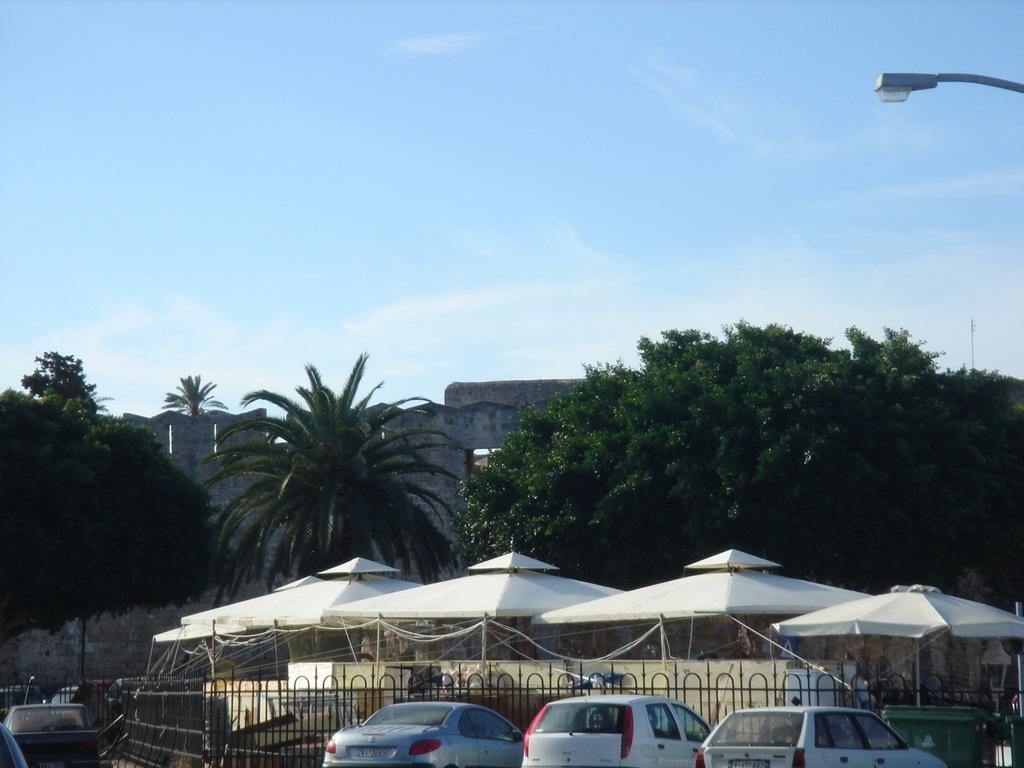In one or two sentences, can you explain what this image depicts? At the bottom of the image there are few vehicles parked on the road, in front of them there is a shed and fencing with metal. In the middle of the image there are few trees and building. On the right side there is a lamp attached to the pole. In the background there is a sky. 